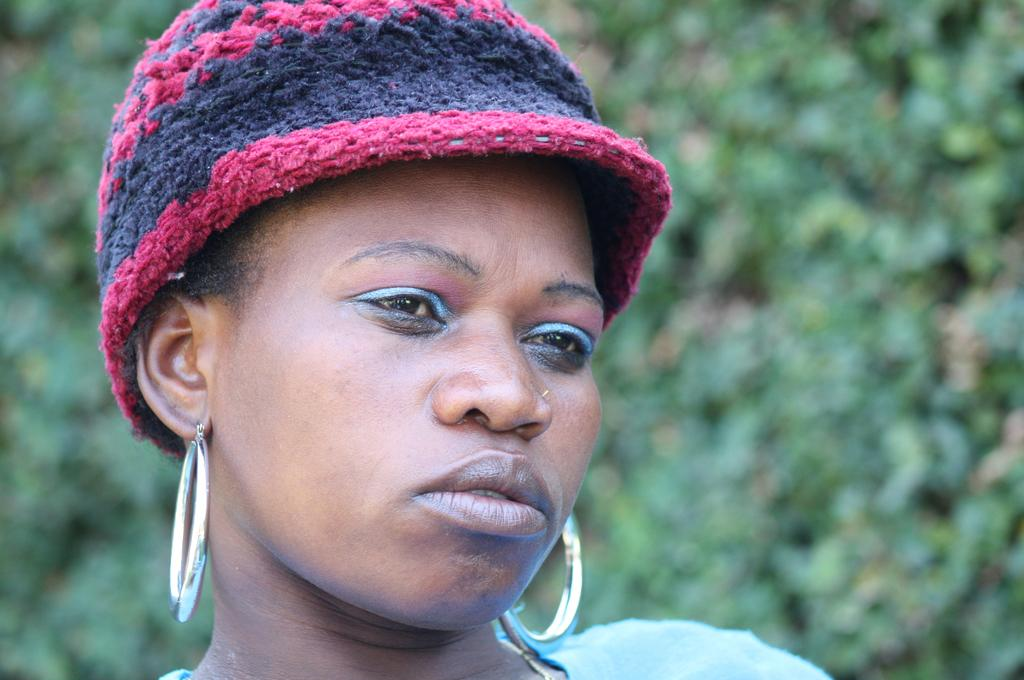What is the ethnicity of the woman in the image? The woman in the image is black. What is the woman wearing on her head? The woman is wearing a cap over her head. What type of accessory can be seen on the woman? The woman has earrings. What can be seen in the background of the image? There are plants in the background of the image. How many steps does the woman take in the image? The image does not show the woman taking any steps, so it cannot be determined from the image. 